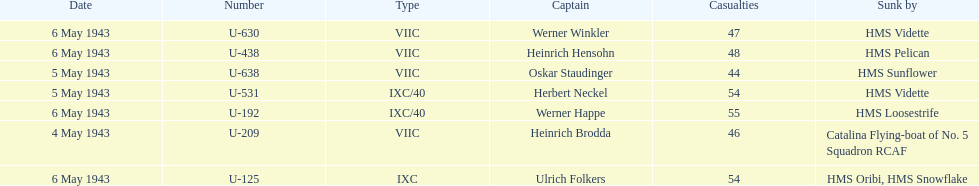Which sunken u-boat had the most casualties U-192. 